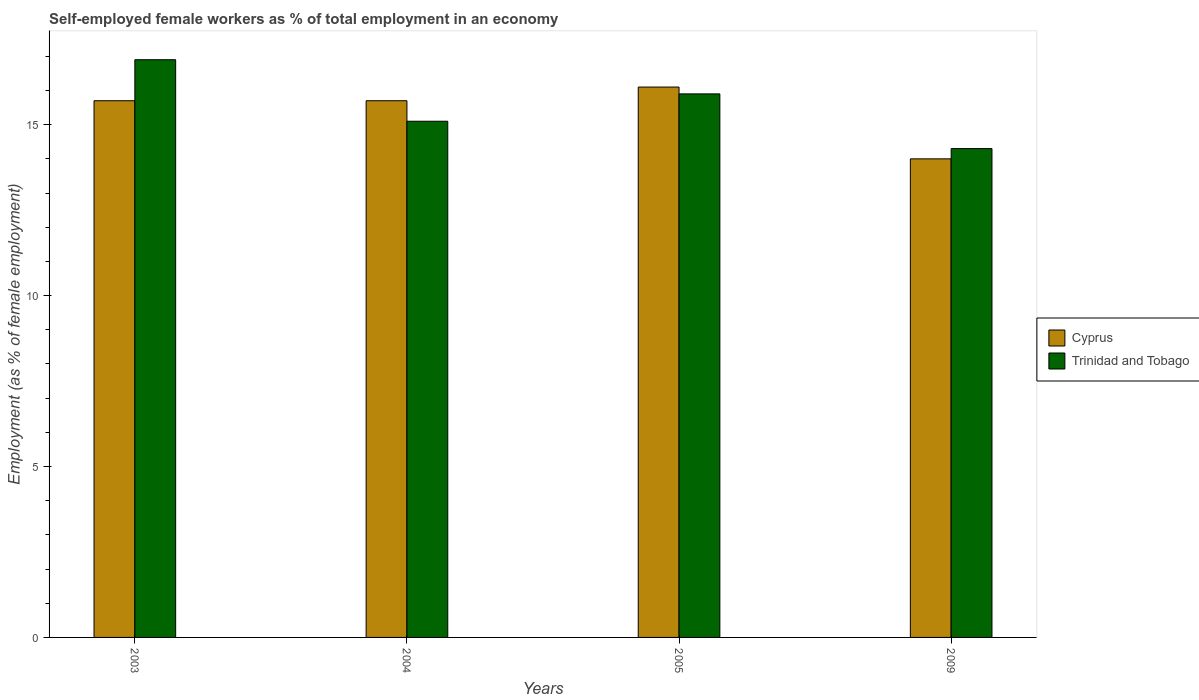How many different coloured bars are there?
Your response must be concise. 2. Are the number of bars per tick equal to the number of legend labels?
Offer a terse response. Yes. Are the number of bars on each tick of the X-axis equal?
Ensure brevity in your answer.  Yes. What is the label of the 4th group of bars from the left?
Offer a very short reply. 2009. What is the percentage of self-employed female workers in Trinidad and Tobago in 2009?
Provide a short and direct response. 14.3. Across all years, what is the maximum percentage of self-employed female workers in Cyprus?
Provide a succinct answer. 16.1. Across all years, what is the minimum percentage of self-employed female workers in Trinidad and Tobago?
Your response must be concise. 14.3. In which year was the percentage of self-employed female workers in Cyprus maximum?
Offer a terse response. 2005. What is the total percentage of self-employed female workers in Trinidad and Tobago in the graph?
Give a very brief answer. 62.2. What is the difference between the percentage of self-employed female workers in Cyprus in 2003 and that in 2004?
Keep it short and to the point. 0. What is the difference between the percentage of self-employed female workers in Trinidad and Tobago in 2003 and the percentage of self-employed female workers in Cyprus in 2005?
Keep it short and to the point. 0.8. What is the average percentage of self-employed female workers in Cyprus per year?
Give a very brief answer. 15.37. In the year 2004, what is the difference between the percentage of self-employed female workers in Trinidad and Tobago and percentage of self-employed female workers in Cyprus?
Give a very brief answer. -0.6. In how many years, is the percentage of self-employed female workers in Trinidad and Tobago greater than 12 %?
Offer a terse response. 4. What is the ratio of the percentage of self-employed female workers in Cyprus in 2003 to that in 2009?
Provide a short and direct response. 1.12. Is the difference between the percentage of self-employed female workers in Trinidad and Tobago in 2003 and 2005 greater than the difference between the percentage of self-employed female workers in Cyprus in 2003 and 2005?
Keep it short and to the point. Yes. What is the difference between the highest and the second highest percentage of self-employed female workers in Trinidad and Tobago?
Offer a terse response. 1. What is the difference between the highest and the lowest percentage of self-employed female workers in Cyprus?
Your answer should be very brief. 2.1. In how many years, is the percentage of self-employed female workers in Trinidad and Tobago greater than the average percentage of self-employed female workers in Trinidad and Tobago taken over all years?
Ensure brevity in your answer.  2. What does the 1st bar from the left in 2004 represents?
Provide a succinct answer. Cyprus. What does the 2nd bar from the right in 2004 represents?
Your answer should be compact. Cyprus. What is the difference between two consecutive major ticks on the Y-axis?
Offer a very short reply. 5. Does the graph contain any zero values?
Provide a succinct answer. No. Does the graph contain grids?
Offer a terse response. No. Where does the legend appear in the graph?
Ensure brevity in your answer.  Center right. How many legend labels are there?
Your answer should be compact. 2. How are the legend labels stacked?
Your answer should be compact. Vertical. What is the title of the graph?
Offer a terse response. Self-employed female workers as % of total employment in an economy. What is the label or title of the Y-axis?
Provide a short and direct response. Employment (as % of female employment). What is the Employment (as % of female employment) in Cyprus in 2003?
Your response must be concise. 15.7. What is the Employment (as % of female employment) in Trinidad and Tobago in 2003?
Offer a very short reply. 16.9. What is the Employment (as % of female employment) of Cyprus in 2004?
Your answer should be compact. 15.7. What is the Employment (as % of female employment) in Trinidad and Tobago in 2004?
Ensure brevity in your answer.  15.1. What is the Employment (as % of female employment) in Cyprus in 2005?
Offer a very short reply. 16.1. What is the Employment (as % of female employment) in Trinidad and Tobago in 2005?
Provide a short and direct response. 15.9. What is the Employment (as % of female employment) of Cyprus in 2009?
Offer a very short reply. 14. What is the Employment (as % of female employment) in Trinidad and Tobago in 2009?
Give a very brief answer. 14.3. Across all years, what is the maximum Employment (as % of female employment) in Cyprus?
Give a very brief answer. 16.1. Across all years, what is the maximum Employment (as % of female employment) of Trinidad and Tobago?
Provide a short and direct response. 16.9. Across all years, what is the minimum Employment (as % of female employment) in Trinidad and Tobago?
Offer a very short reply. 14.3. What is the total Employment (as % of female employment) of Cyprus in the graph?
Provide a succinct answer. 61.5. What is the total Employment (as % of female employment) of Trinidad and Tobago in the graph?
Offer a terse response. 62.2. What is the difference between the Employment (as % of female employment) of Cyprus in 2003 and that in 2005?
Ensure brevity in your answer.  -0.4. What is the difference between the Employment (as % of female employment) in Trinidad and Tobago in 2003 and that in 2005?
Your answer should be very brief. 1. What is the difference between the Employment (as % of female employment) of Cyprus in 2003 and that in 2009?
Offer a very short reply. 1.7. What is the difference between the Employment (as % of female employment) of Cyprus in 2004 and that in 2005?
Provide a succinct answer. -0.4. What is the difference between the Employment (as % of female employment) in Cyprus in 2004 and that in 2009?
Your answer should be compact. 1.7. What is the difference between the Employment (as % of female employment) in Trinidad and Tobago in 2004 and that in 2009?
Your response must be concise. 0.8. What is the difference between the Employment (as % of female employment) of Cyprus in 2005 and that in 2009?
Provide a short and direct response. 2.1. What is the difference between the Employment (as % of female employment) of Trinidad and Tobago in 2005 and that in 2009?
Provide a short and direct response. 1.6. What is the difference between the Employment (as % of female employment) of Cyprus in 2003 and the Employment (as % of female employment) of Trinidad and Tobago in 2009?
Offer a very short reply. 1.4. What is the difference between the Employment (as % of female employment) of Cyprus in 2004 and the Employment (as % of female employment) of Trinidad and Tobago in 2005?
Your answer should be very brief. -0.2. What is the difference between the Employment (as % of female employment) of Cyprus in 2005 and the Employment (as % of female employment) of Trinidad and Tobago in 2009?
Keep it short and to the point. 1.8. What is the average Employment (as % of female employment) of Cyprus per year?
Ensure brevity in your answer.  15.38. What is the average Employment (as % of female employment) of Trinidad and Tobago per year?
Offer a very short reply. 15.55. What is the ratio of the Employment (as % of female employment) of Trinidad and Tobago in 2003 to that in 2004?
Your answer should be very brief. 1.12. What is the ratio of the Employment (as % of female employment) in Cyprus in 2003 to that in 2005?
Ensure brevity in your answer.  0.98. What is the ratio of the Employment (as % of female employment) in Trinidad and Tobago in 2003 to that in 2005?
Your answer should be very brief. 1.06. What is the ratio of the Employment (as % of female employment) of Cyprus in 2003 to that in 2009?
Provide a short and direct response. 1.12. What is the ratio of the Employment (as % of female employment) of Trinidad and Tobago in 2003 to that in 2009?
Your answer should be very brief. 1.18. What is the ratio of the Employment (as % of female employment) of Cyprus in 2004 to that in 2005?
Your answer should be very brief. 0.98. What is the ratio of the Employment (as % of female employment) in Trinidad and Tobago in 2004 to that in 2005?
Offer a very short reply. 0.95. What is the ratio of the Employment (as % of female employment) in Cyprus in 2004 to that in 2009?
Your answer should be very brief. 1.12. What is the ratio of the Employment (as % of female employment) in Trinidad and Tobago in 2004 to that in 2009?
Your answer should be very brief. 1.06. What is the ratio of the Employment (as % of female employment) in Cyprus in 2005 to that in 2009?
Your answer should be compact. 1.15. What is the ratio of the Employment (as % of female employment) in Trinidad and Tobago in 2005 to that in 2009?
Offer a very short reply. 1.11. What is the difference between the highest and the second highest Employment (as % of female employment) in Cyprus?
Offer a very short reply. 0.4. What is the difference between the highest and the second highest Employment (as % of female employment) of Trinidad and Tobago?
Your answer should be very brief. 1. 